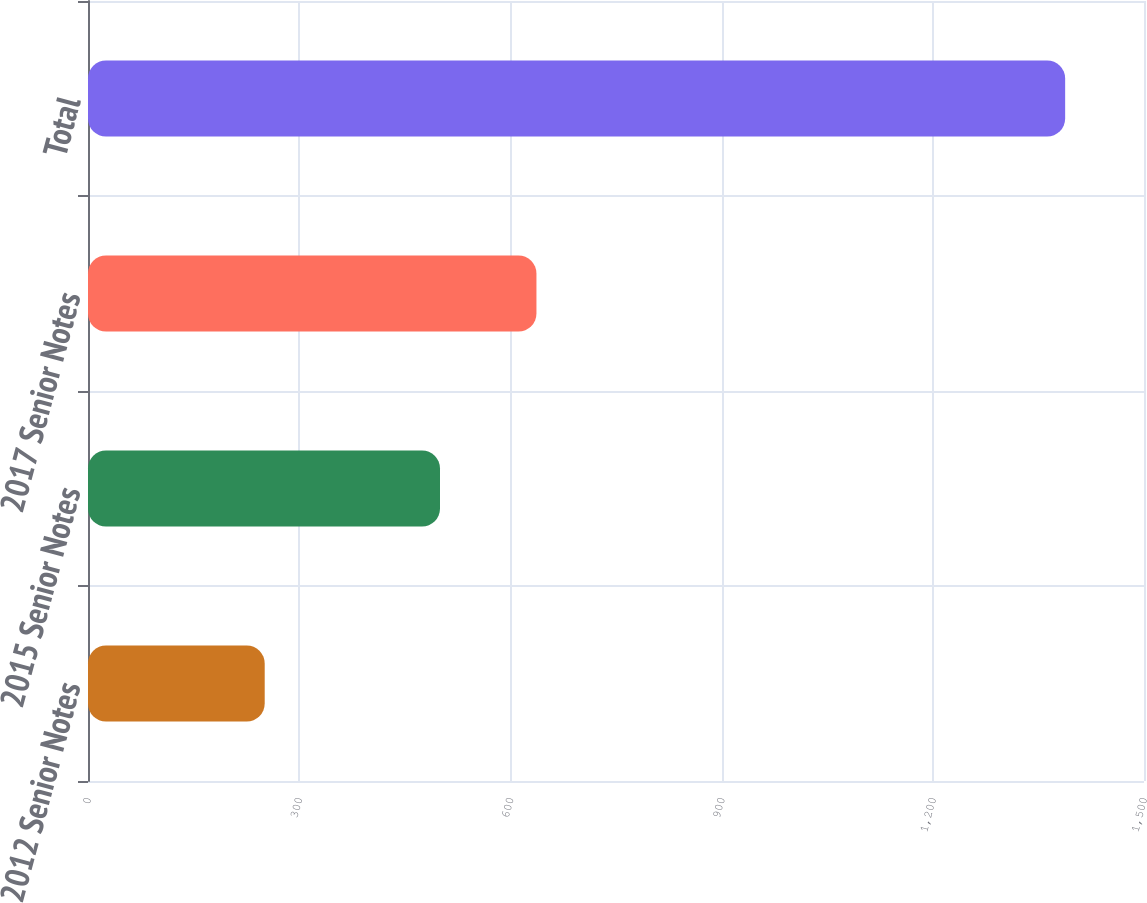Convert chart to OTSL. <chart><loc_0><loc_0><loc_500><loc_500><bar_chart><fcel>2012 Senior Notes<fcel>2015 Senior Notes<fcel>2017 Senior Notes<fcel>Total<nl><fcel>251<fcel>500<fcel>637<fcel>1388<nl></chart> 